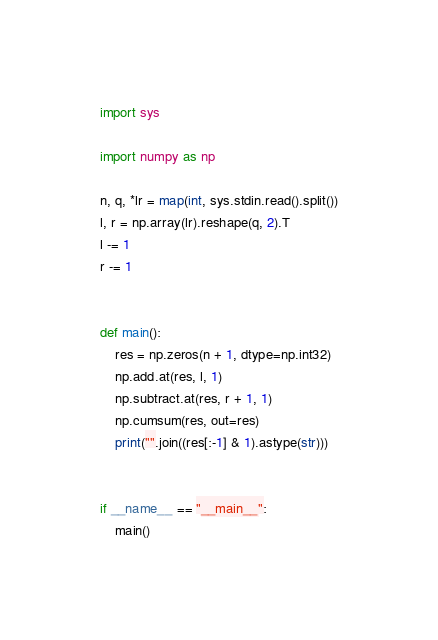Convert code to text. <code><loc_0><loc_0><loc_500><loc_500><_Python_>import sys

import numpy as np

n, q, *lr = map(int, sys.stdin.read().split())
l, r = np.array(lr).reshape(q, 2).T
l -= 1
r -= 1


def main():
    res = np.zeros(n + 1, dtype=np.int32)
    np.add.at(res, l, 1)
    np.subtract.at(res, r + 1, 1)
    np.cumsum(res, out=res)
    print("".join((res[:-1] & 1).astype(str)))


if __name__ == "__main__":
    main()
</code> 